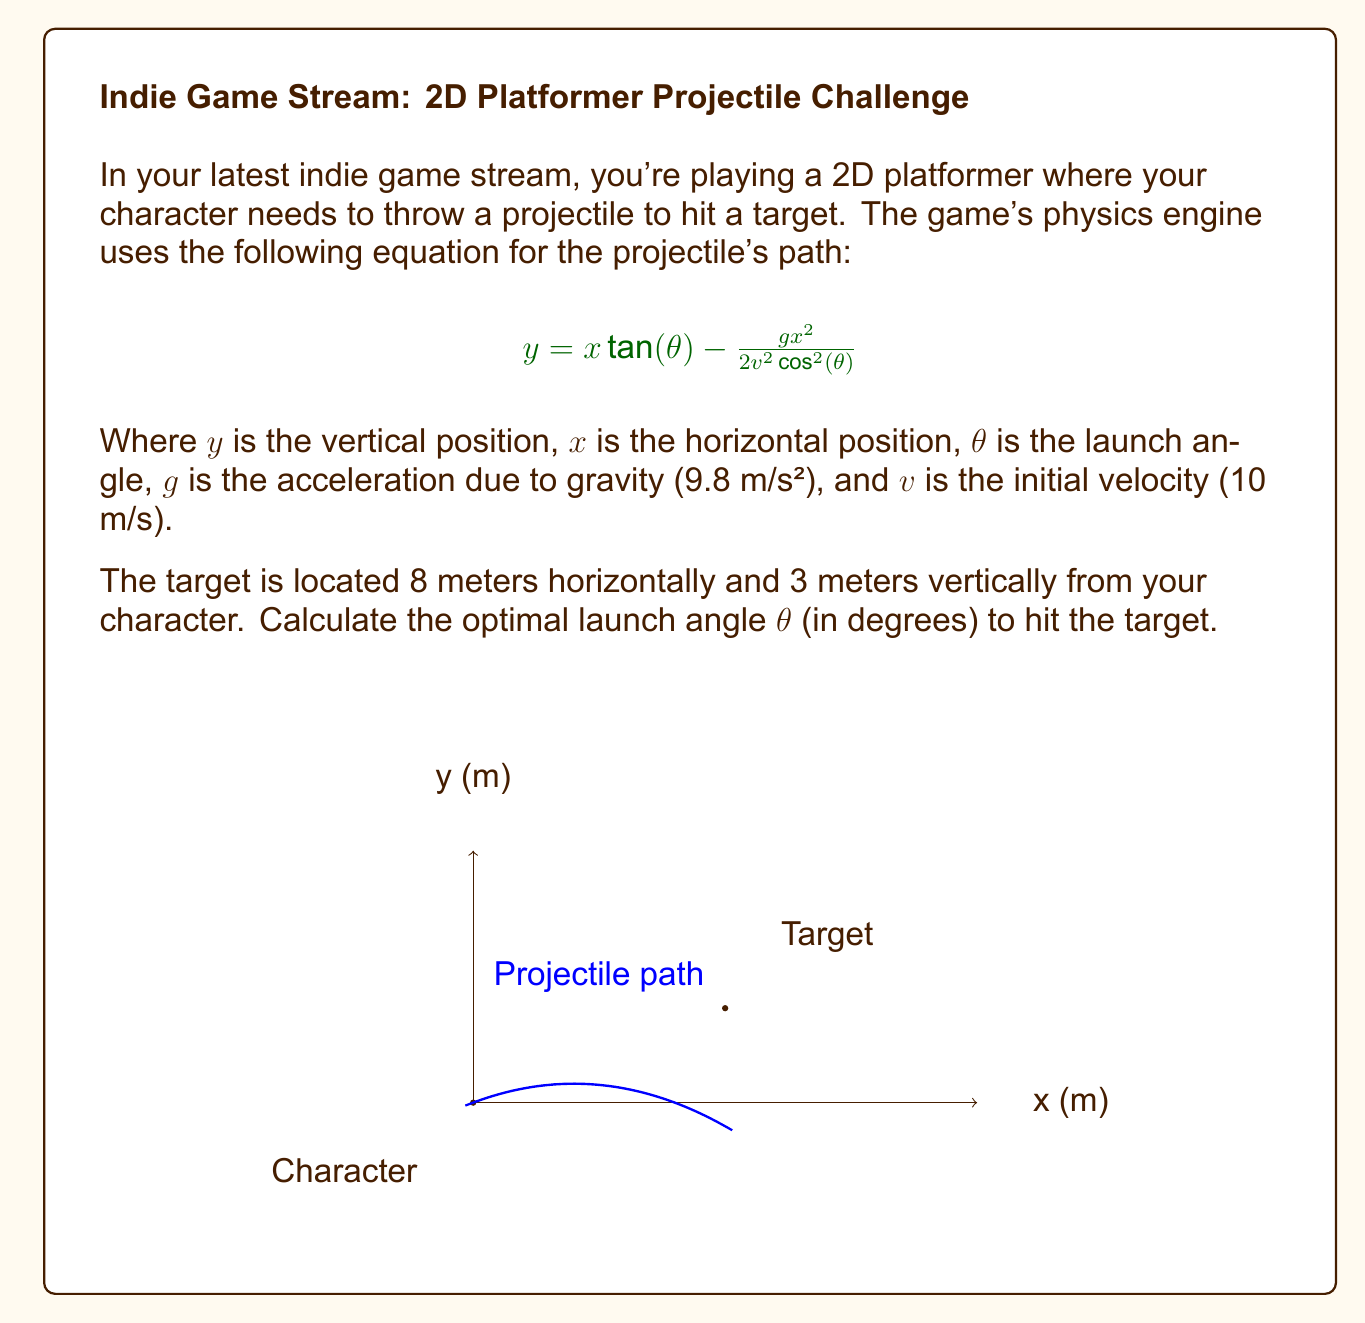Can you solve this math problem? Let's approach this step-by-step:

1) We know the target coordinates: $x = 8$ m, $y = 3$ m.

2) Substituting these values into the projectile equation:

   $$3 = 8 \tan(\theta) - \frac{9.8 \cdot 8^2}{2 \cdot 10^2 \cos^2(\theta)}$$

3) Simplify:

   $$3 = 8 \tan(\theta) - \frac{3.136}{\cos^2(\theta)}$$

4) Multiply both sides by $\cos^2(\theta)$:

   $$3\cos^2(\theta) = 8\sin(\theta)\cos(\theta) - 3.136$$

5) Use the identity $\sin(2\theta) = 2\sin(\theta)\cos(\theta)$:

   $$3\cos^2(\theta) = 4\sin(2\theta) - 3.136$$

6) Use the identity $\cos^2(\theta) = \frac{1 + \cos(2\theta)}{2}$:

   $$3\left(\frac{1 + \cos(2\theta)}{2}\right) = 4\sin(2\theta) - 3.136$$

7) Simplify:

   $$1.5 + 1.5\cos(2\theta) = 4\sin(2\theta) - 3.136$$

8) Rearrange:

   $$4\sin(2\theta) - 1.5\cos(2\theta) = 4.636$$

9) Divide both sides by $\sqrt{4^2 + 1.5^2} \approx 4.272$:

   $$0.9363\sin(2\theta) - 0.3511\cos(2\theta) = 1.0853$$

10) This is in the form $a\sin(2\theta) + b\cos(2\theta) = c$, which has the solution:

    $$2\theta = \arcsin(c) + \arctan(b/a)$$

11) Substitute our values:

    $$2\theta = \arcsin(1.0853) + \arctan(-0.3511/0.9363)$$

12) Solve:

    $$2\theta = 1.5708 - 0.3587 = 1.2121 \text{ radians}$$

13) Divide by 2 and convert to degrees:

    $$\theta = 0.6060 \text{ radians} = 34.72°$$
Answer: $34.72°$ 